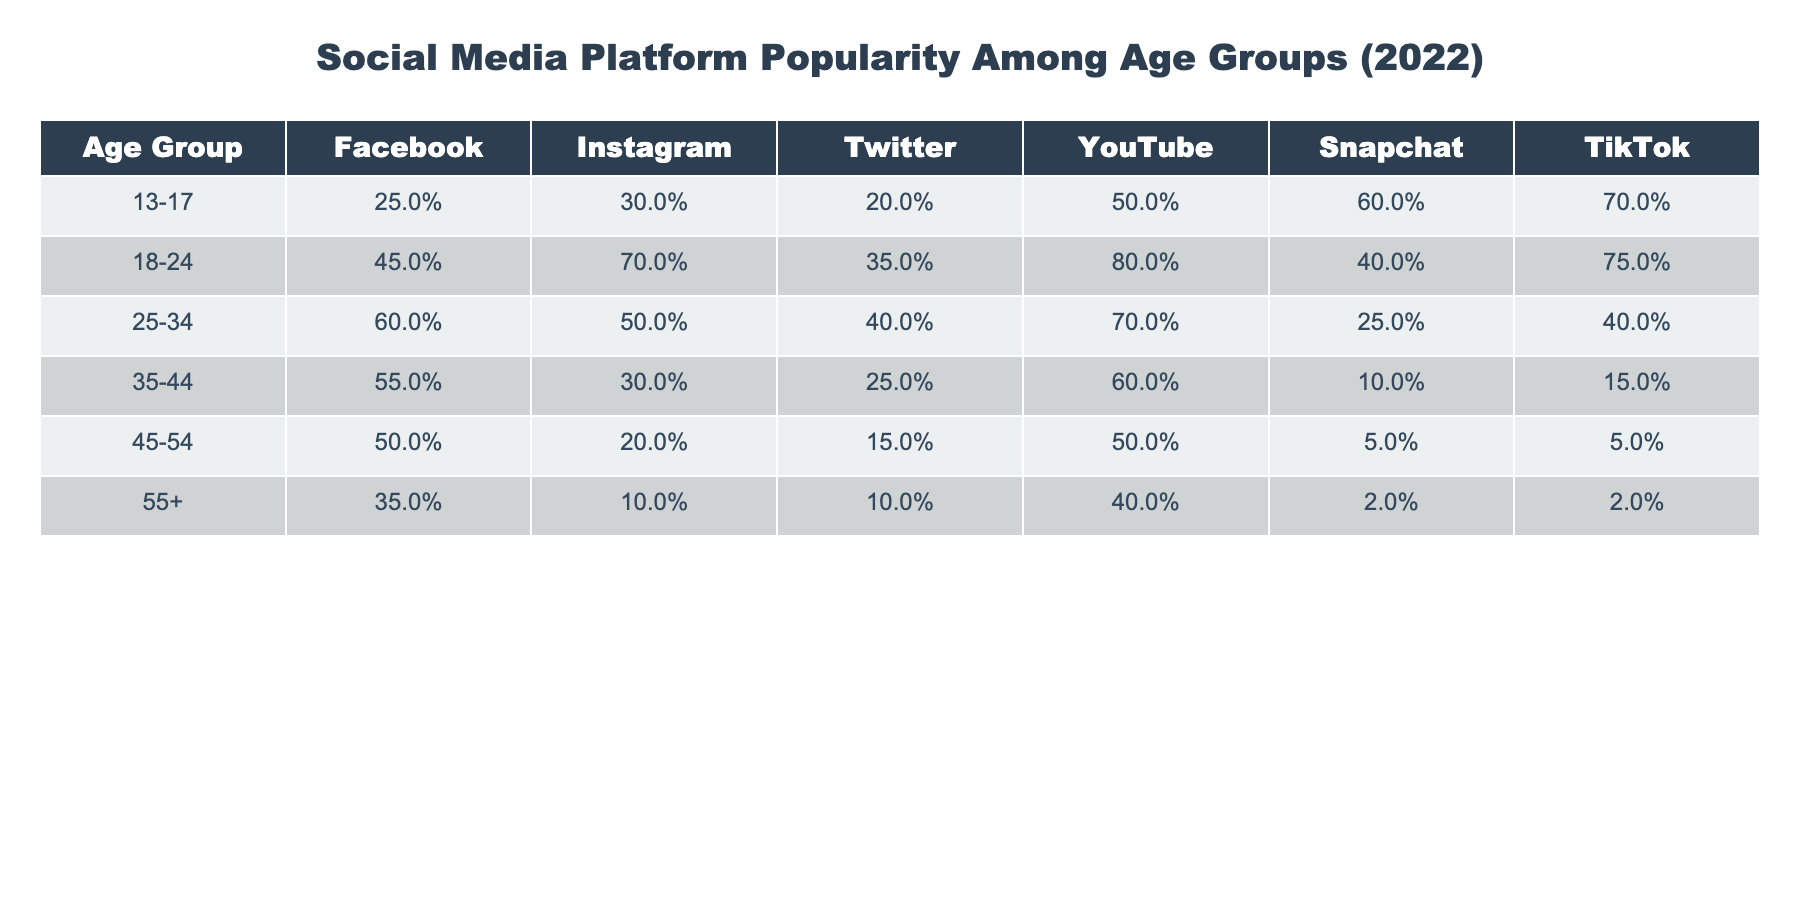What percentage of 13-17 year-olds use Snapchat? According to the table, 60% of the 13-17 age group use Snapchat.
Answer: 60% Which social media platform is most popular among 18-24 year-olds? The table shows that 80% of 18-24 year-olds use YouTube, which is the highest percentage compared to other platforms in that age group.
Answer: YouTube What is the percentage difference in Instagram usage between the 25-34 and 35-44 age groups? Instagram usage for the 25-34 age group is 50%, and for the 35-44 age group is 30%. Thus, the difference is 50% - 30% = 20%.
Answer: 20% True or false: More than 50% of people aged 45-54 use Facebook. The table states that 50% of the 45-54 age group uses Facebook, which is not more than 50%.
Answer: False For which age group is TikTok least popular, and what is the percentage? The 55+ age group shows the least popularity for TikTok, with a usage rate of 2%.
Answer: 55+, 2% What is the average percentage of YouTube users across all age groups? To find the average, add the percentages for all age groups: (50 + 80 + 70 + 60 + 50 + 40) = 350. There are 6 age groups, so the average is 350/6 = approximately 58.33%.
Answer: 58.33% Which two age groups have the lowest percentage of Snapchat users, and what are those percentages? The table indicates that the 35-44 age group uses Snapchat at 10%, and the 45-54 age group at 5%. These are the two lowest percentages.
Answer: 10%, 5% Does the percentage of Twitter users increase or decrease from the 18-24 to the 25-34 age group? In the table, Twitter usage decreases from 35% among the 18-24 age group to 40% in the 25-34 age group.
Answer: Increase Which platforms are used more than 50% by the 25-34 age group? For the 25-34 age group, the platforms used more than 50% include Facebook (60%), YouTube (70%), indicating that more than half of this age group uses these platforms.
Answer: Facebook, YouTube What percentage of 55+ year-olds use Instagram? The table reveals that only 10% of the 55+ age group use Instagram.
Answer: 10% 